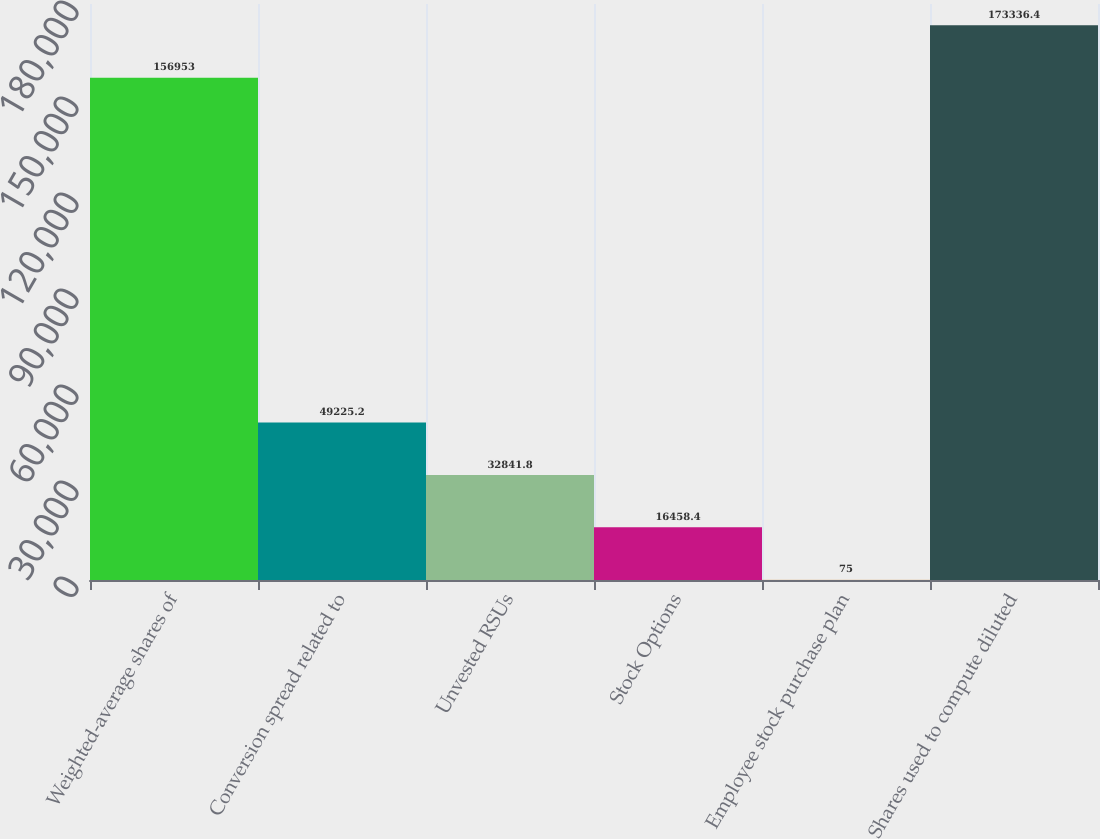<chart> <loc_0><loc_0><loc_500><loc_500><bar_chart><fcel>Weighted-average shares of<fcel>Conversion spread related to<fcel>Unvested RSUs<fcel>Stock Options<fcel>Employee stock purchase plan<fcel>Shares used to compute diluted<nl><fcel>156953<fcel>49225.2<fcel>32841.8<fcel>16458.4<fcel>75<fcel>173336<nl></chart> 